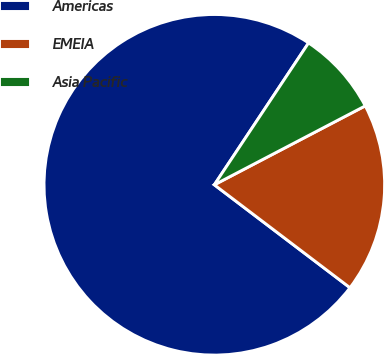<chart> <loc_0><loc_0><loc_500><loc_500><pie_chart><fcel>Americas<fcel>EMEIA<fcel>Asia Pacific<nl><fcel>74.0%<fcel>18.0%<fcel>8.0%<nl></chart> 